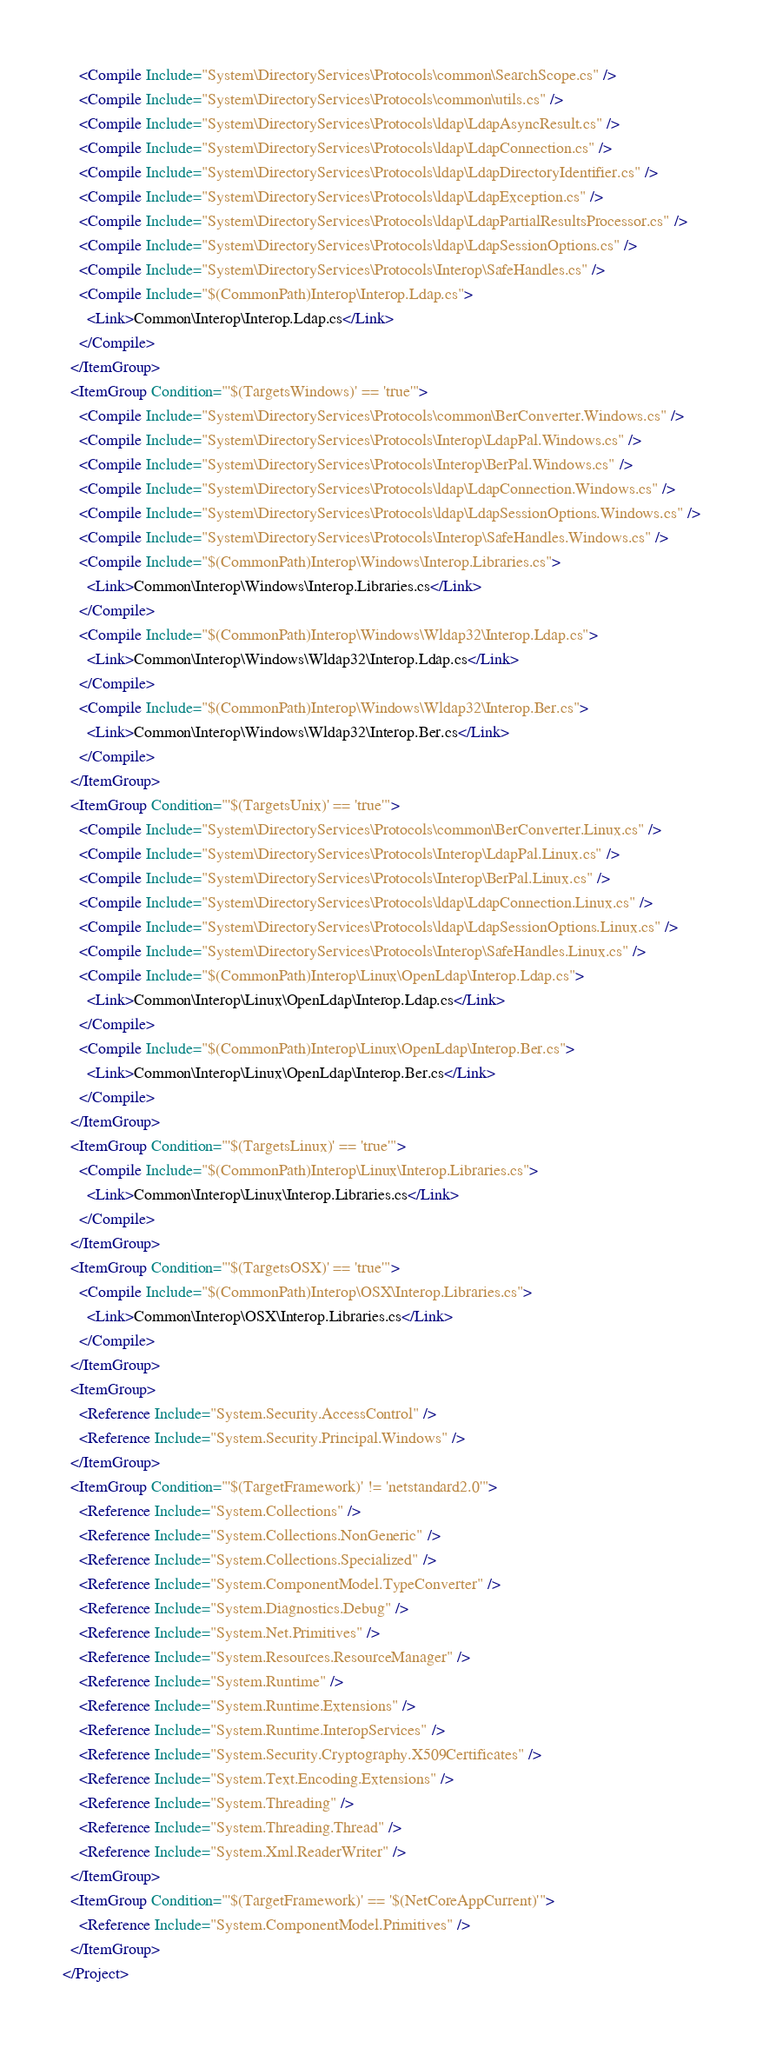<code> <loc_0><loc_0><loc_500><loc_500><_XML_>    <Compile Include="System\DirectoryServices\Protocols\common\SearchScope.cs" />
    <Compile Include="System\DirectoryServices\Protocols\common\utils.cs" />
    <Compile Include="System\DirectoryServices\Protocols\ldap\LdapAsyncResult.cs" />
    <Compile Include="System\DirectoryServices\Protocols\ldap\LdapConnection.cs" />
    <Compile Include="System\DirectoryServices\Protocols\ldap\LdapDirectoryIdentifier.cs" />
    <Compile Include="System\DirectoryServices\Protocols\ldap\LdapException.cs" />
    <Compile Include="System\DirectoryServices\Protocols\ldap\LdapPartialResultsProcessor.cs" />
    <Compile Include="System\DirectoryServices\Protocols\ldap\LdapSessionOptions.cs" />
    <Compile Include="System\DirectoryServices\Protocols\Interop\SafeHandles.cs" />
    <Compile Include="$(CommonPath)Interop\Interop.Ldap.cs">
      <Link>Common\Interop\Interop.Ldap.cs</Link>
    </Compile>
  </ItemGroup>
  <ItemGroup Condition="'$(TargetsWindows)' == 'true'">
    <Compile Include="System\DirectoryServices\Protocols\common\BerConverter.Windows.cs" />
    <Compile Include="System\DirectoryServices\Protocols\Interop\LdapPal.Windows.cs" />
    <Compile Include="System\DirectoryServices\Protocols\Interop\BerPal.Windows.cs" />
    <Compile Include="System\DirectoryServices\Protocols\ldap\LdapConnection.Windows.cs" />
    <Compile Include="System\DirectoryServices\Protocols\ldap\LdapSessionOptions.Windows.cs" />
    <Compile Include="System\DirectoryServices\Protocols\Interop\SafeHandles.Windows.cs" />
    <Compile Include="$(CommonPath)Interop\Windows\Interop.Libraries.cs">
      <Link>Common\Interop\Windows\Interop.Libraries.cs</Link>
    </Compile>
    <Compile Include="$(CommonPath)Interop\Windows\Wldap32\Interop.Ldap.cs">
      <Link>Common\Interop\Windows\Wldap32\Interop.Ldap.cs</Link>
    </Compile>
    <Compile Include="$(CommonPath)Interop\Windows\Wldap32\Interop.Ber.cs">
      <Link>Common\Interop\Windows\Wldap32\Interop.Ber.cs</Link>
    </Compile>
  </ItemGroup>
  <ItemGroup Condition="'$(TargetsUnix)' == 'true'">
    <Compile Include="System\DirectoryServices\Protocols\common\BerConverter.Linux.cs" />
    <Compile Include="System\DirectoryServices\Protocols\Interop\LdapPal.Linux.cs" />
    <Compile Include="System\DirectoryServices\Protocols\Interop\BerPal.Linux.cs" />
    <Compile Include="System\DirectoryServices\Protocols\ldap\LdapConnection.Linux.cs" />
    <Compile Include="System\DirectoryServices\Protocols\ldap\LdapSessionOptions.Linux.cs" />
    <Compile Include="System\DirectoryServices\Protocols\Interop\SafeHandles.Linux.cs" />
    <Compile Include="$(CommonPath)Interop\Linux\OpenLdap\Interop.Ldap.cs">
      <Link>Common\Interop\Linux\OpenLdap\Interop.Ldap.cs</Link>
    </Compile>
    <Compile Include="$(CommonPath)Interop\Linux\OpenLdap\Interop.Ber.cs">
      <Link>Common\Interop\Linux\OpenLdap\Interop.Ber.cs</Link>
    </Compile>
  </ItemGroup>
  <ItemGroup Condition="'$(TargetsLinux)' == 'true'">
    <Compile Include="$(CommonPath)Interop\Linux\Interop.Libraries.cs">
      <Link>Common\Interop\Linux\Interop.Libraries.cs</Link>
    </Compile>
  </ItemGroup>
  <ItemGroup Condition="'$(TargetsOSX)' == 'true'">
    <Compile Include="$(CommonPath)Interop\OSX\Interop.Libraries.cs">
      <Link>Common\Interop\OSX\Interop.Libraries.cs</Link>
    </Compile>
  </ItemGroup>
  <ItemGroup>
    <Reference Include="System.Security.AccessControl" />
    <Reference Include="System.Security.Principal.Windows" />
  </ItemGroup>
  <ItemGroup Condition="'$(TargetFramework)' != 'netstandard2.0'">
    <Reference Include="System.Collections" />
    <Reference Include="System.Collections.NonGeneric" />
    <Reference Include="System.Collections.Specialized" />
    <Reference Include="System.ComponentModel.TypeConverter" />
    <Reference Include="System.Diagnostics.Debug" />
    <Reference Include="System.Net.Primitives" />
    <Reference Include="System.Resources.ResourceManager" />
    <Reference Include="System.Runtime" />
    <Reference Include="System.Runtime.Extensions" />
    <Reference Include="System.Runtime.InteropServices" />
    <Reference Include="System.Security.Cryptography.X509Certificates" />
    <Reference Include="System.Text.Encoding.Extensions" />
    <Reference Include="System.Threading" />
    <Reference Include="System.Threading.Thread" />
    <Reference Include="System.Xml.ReaderWriter" />
  </ItemGroup>
  <ItemGroup Condition="'$(TargetFramework)' == '$(NetCoreAppCurrent)'">
    <Reference Include="System.ComponentModel.Primitives" />
  </ItemGroup>
</Project>
</code> 